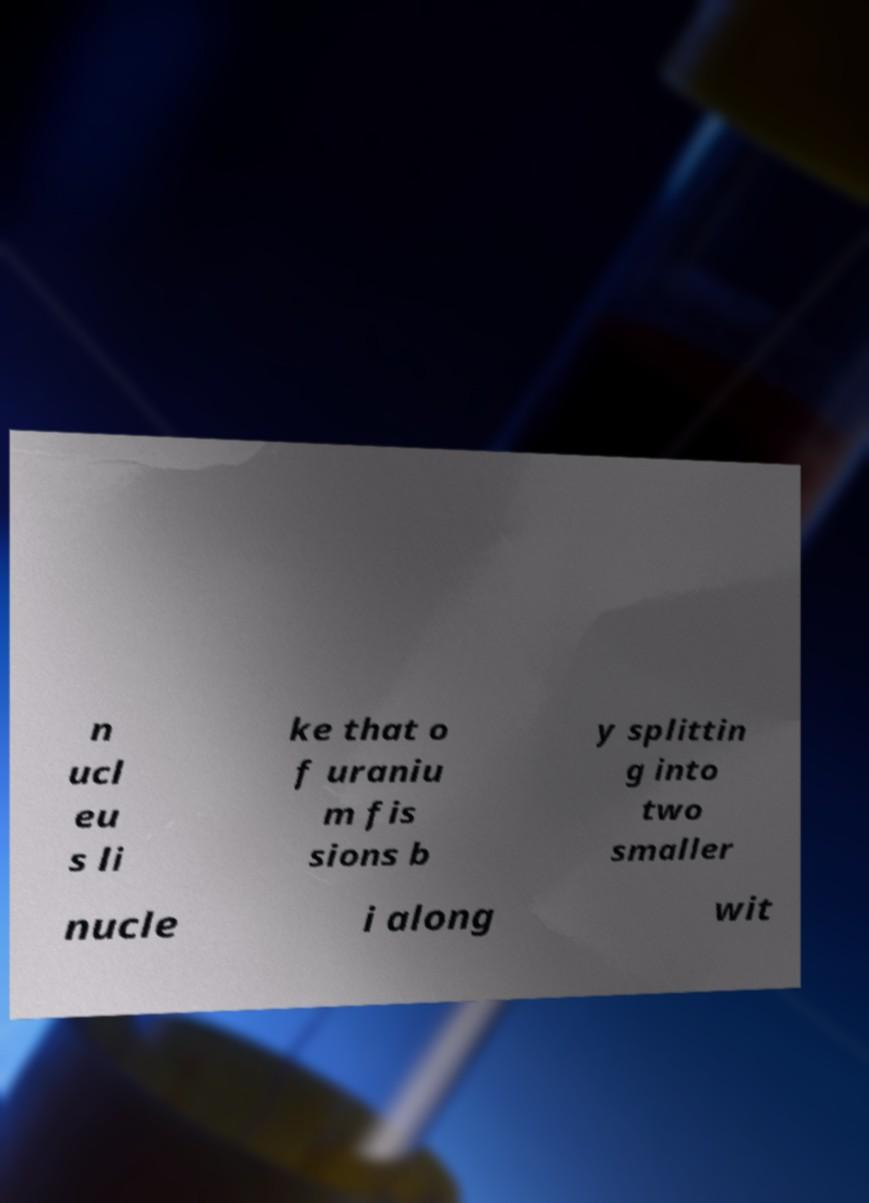What messages or text are displayed in this image? I need them in a readable, typed format. n ucl eu s li ke that o f uraniu m fis sions b y splittin g into two smaller nucle i along wit 